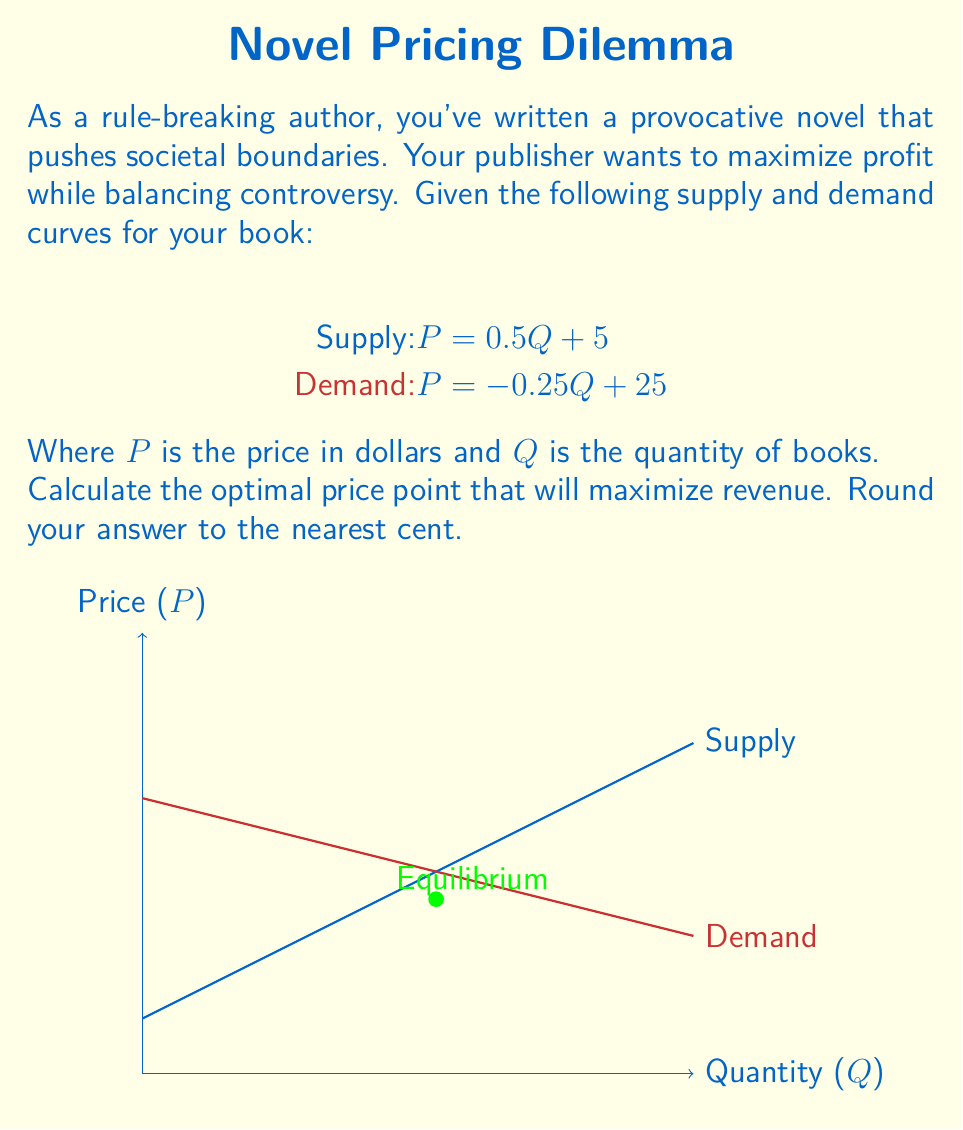What is the answer to this math problem? To find the optimal price point that maximizes revenue, we need to follow these steps:

1) First, find the equilibrium point by equating supply and demand:
   $0.5Q + 5 = -0.25Q + 25$
   $0.75Q = 20$
   $Q = 26.67$

2) The equilibrium price is:
   $P = 0.5(26.67) + 5 = 18.33$

3) However, this equilibrium point doesn't necessarily maximize revenue. To find the revenue-maximizing point, we need to create a revenue function.

4) Revenue is price times quantity. We'll use the demand equation since it represents what consumers are willing to pay:
   $R = PQ = (-0.25Q + 25)Q = -0.25Q^2 + 25Q$

5) To maximize revenue, find where the derivative of the revenue function equals zero:
   $\frac{dR}{dQ} = -0.5Q + 25 = 0$
   $Q = 50$

6) Now that we know the optimal quantity, plug this back into the demand equation to find the optimal price:
   $P = -0.25(50) + 25 = 12.5$

7) Therefore, the optimal price point is $12.50.

This price point is lower than the equilibrium price, which aligns with the persona of a rule-breaking author willing to push boundaries by making the provocative novel more accessible to a wider audience.
Answer: $12.50 